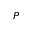<formula> <loc_0><loc_0><loc_500><loc_500>P</formula> 